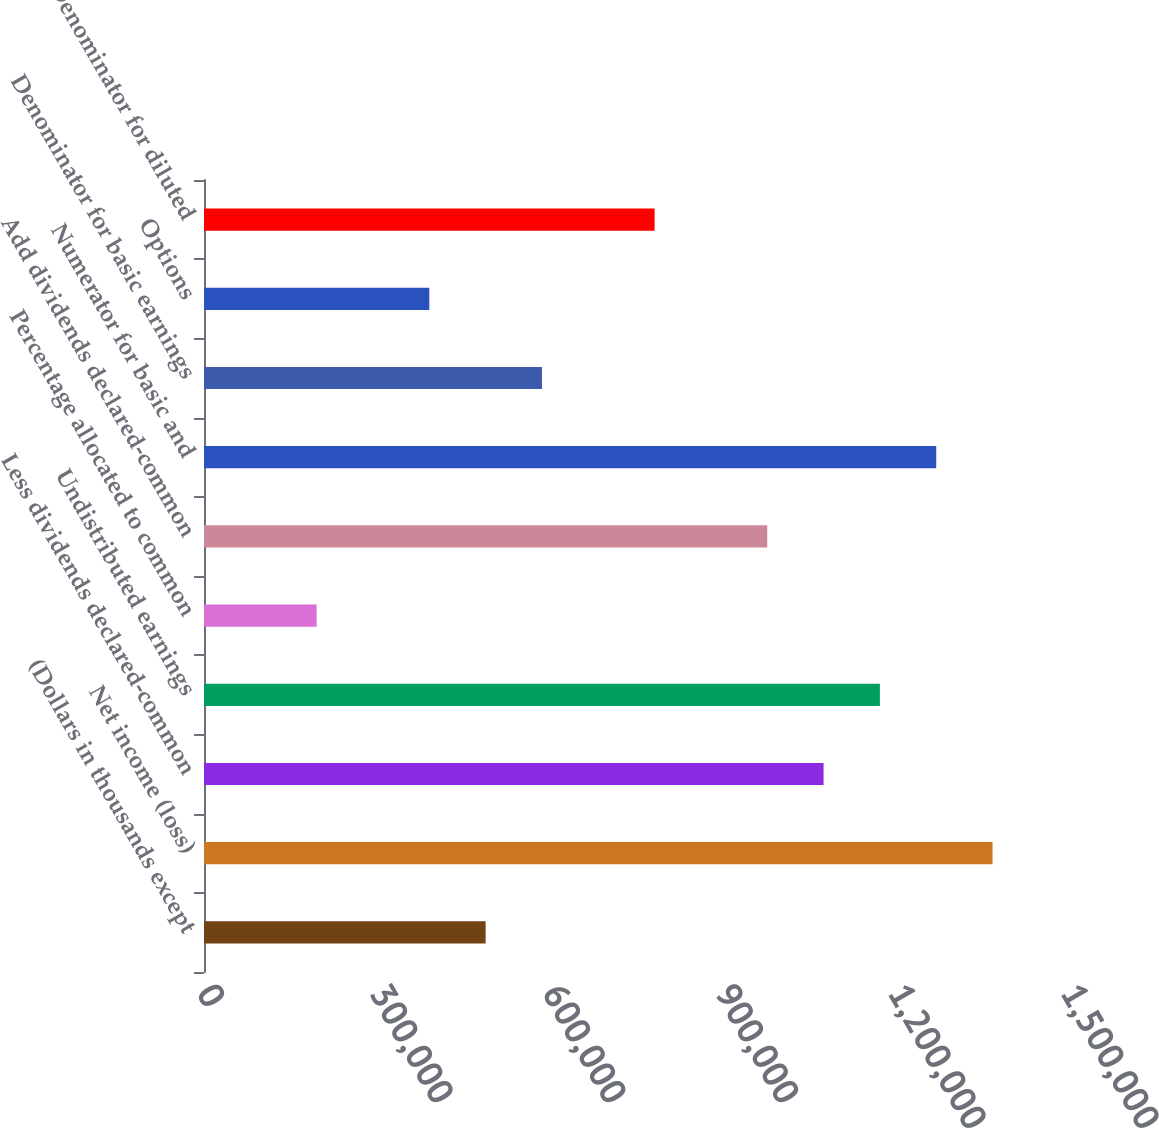<chart> <loc_0><loc_0><loc_500><loc_500><bar_chart><fcel>(Dollars in thousands except<fcel>Net income (loss)<fcel>Less dividends declared-common<fcel>Undistributed earnings<fcel>Percentage allocated to common<fcel>Add dividends declared-common<fcel>Numerator for basic and<fcel>Denominator for basic earnings<fcel>Options<fcel>Denominator for diluted<nl><fcel>488946<fcel>1.36901e+06<fcel>1.07565e+06<fcel>1.17344e+06<fcel>195591<fcel>977869<fcel>1.27122e+06<fcel>586730<fcel>391161<fcel>782300<nl></chart> 